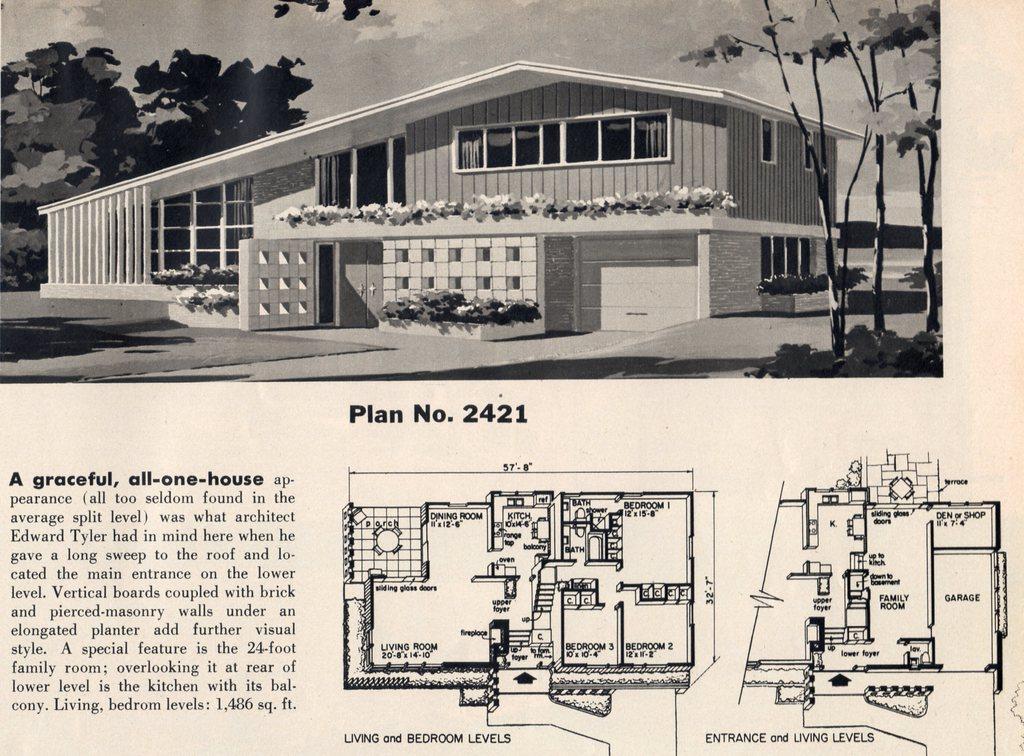Please provide a concise description of this image. It is a poster. In this image there is a building. There are plants, trees. In the background of the image there is sky. There is some text and drawing on the image. 